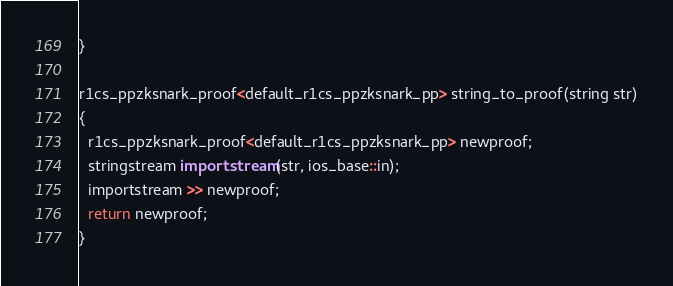Convert code to text. <code><loc_0><loc_0><loc_500><loc_500><_C++_>}

r1cs_ppzksnark_proof<default_r1cs_ppzksnark_pp> string_to_proof(string str)
{
  r1cs_ppzksnark_proof<default_r1cs_ppzksnark_pp> newproof;
  stringstream importstream(str, ios_base::in);
  importstream >> newproof;
  return newproof;
}</code> 